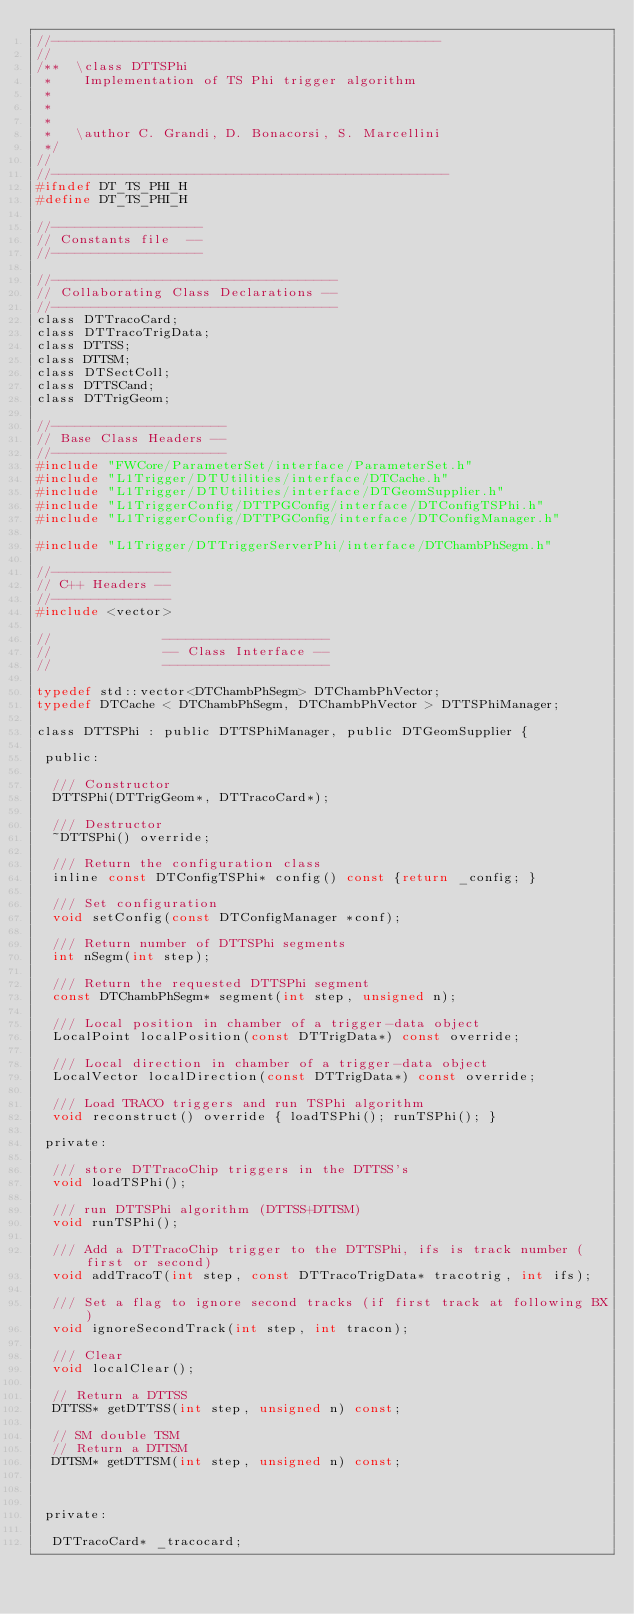<code> <loc_0><loc_0><loc_500><loc_500><_C_>//-------------------------------------------------
//
/**  \class DTTSPhi
 *    Implementation of TS Phi trigger algorithm
 *
 *
 *
 *   \author C. Grandi, D. Bonacorsi, S. Marcellini
 */
//
//--------------------------------------------------
#ifndef DT_TS_PHI_H
#define DT_TS_PHI_H

//-------------------
// Constants file  --
//-------------------

//------------------------------------
// Collaborating Class Declarations --
//------------------------------------
class DTTracoCard;
class DTTracoTrigData;
class DTTSS;
class DTTSM;
class DTSectColl;
class DTTSCand;
class DTTrigGeom;

//----------------------
// Base Class Headers --
//----------------------
#include "FWCore/ParameterSet/interface/ParameterSet.h"
#include "L1Trigger/DTUtilities/interface/DTCache.h"
#include "L1Trigger/DTUtilities/interface/DTGeomSupplier.h"
#include "L1TriggerConfig/DTTPGConfig/interface/DTConfigTSPhi.h"
#include "L1TriggerConfig/DTTPGConfig/interface/DTConfigManager.h"

#include "L1Trigger/DTTriggerServerPhi/interface/DTChambPhSegm.h"

//---------------
// C++ Headers --
//---------------
#include <vector>

//              ---------------------
//              -- Class Interface --
//              ---------------------

typedef std::vector<DTChambPhSegm> DTChambPhVector;
typedef DTCache < DTChambPhSegm, DTChambPhVector > DTTSPhiManager;

class DTTSPhi : public DTTSPhiManager, public DTGeomSupplier {
  
 public:
  
  /// Constructor
  DTTSPhi(DTTrigGeom*, DTTracoCard*);

  /// Destructor 
  ~DTTSPhi() override;

  /// Return the configuration class
  inline const DTConfigTSPhi* config() const {return _config; }

  /// Set configuration
  void setConfig(const DTConfigManager *conf);
  
  /// Return number of DTTSPhi segments  
  int nSegm(int step);
  
  /// Return the requested DTTSPhi segment
  const DTChambPhSegm* segment(int step, unsigned n);
  
  /// Local position in chamber of a trigger-data object
  LocalPoint localPosition(const DTTrigData*) const override;
  
  /// Local direction in chamber of a trigger-data object
  LocalVector localDirection(const DTTrigData*) const override;
  
  /// Load TRACO triggers and run TSPhi algorithm
  void reconstruct() override { loadTSPhi(); runTSPhi(); }

 private:
  
  /// store DTTracoChip triggers in the DTTSS's
  void loadTSPhi();
  
  /// run DTTSPhi algorithm (DTTSS+DTTSM)
  void runTSPhi();
  
  /// Add a DTTracoChip trigger to the DTTSPhi, ifs is track number (first or second)
  void addTracoT(int step, const DTTracoTrigData* tracotrig, int ifs);
  
  /// Set a flag to ignore second tracks (if first track at following BX)
  void ignoreSecondTrack(int step, int tracon);
  
  /// Clear
  void localClear();
  
  // Return a DTTSS
  DTTSS* getDTTSS(int step, unsigned n) const;
  
  // SM double TSM
  // Return a DTTSM
  DTTSM* getDTTSM(int step, unsigned n) const;
  

  
 private:
  
  DTTracoCard* _tracocard;
</code> 